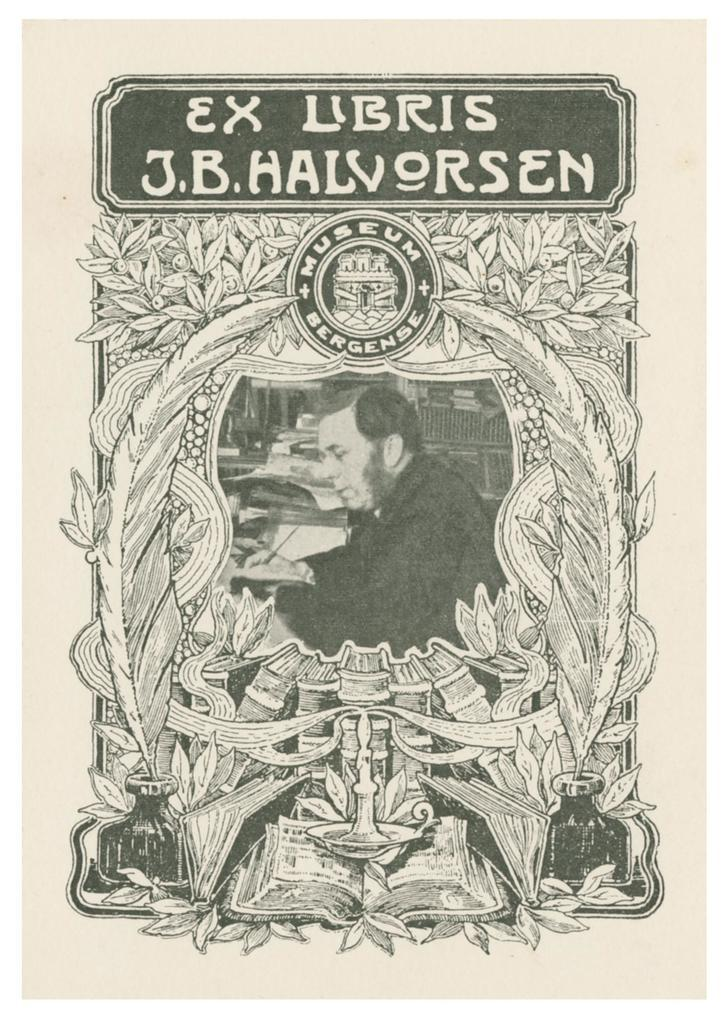<image>
Render a clear and concise summary of the photo. A book titled Ex Libris has an ornately drawn design on the cover. 